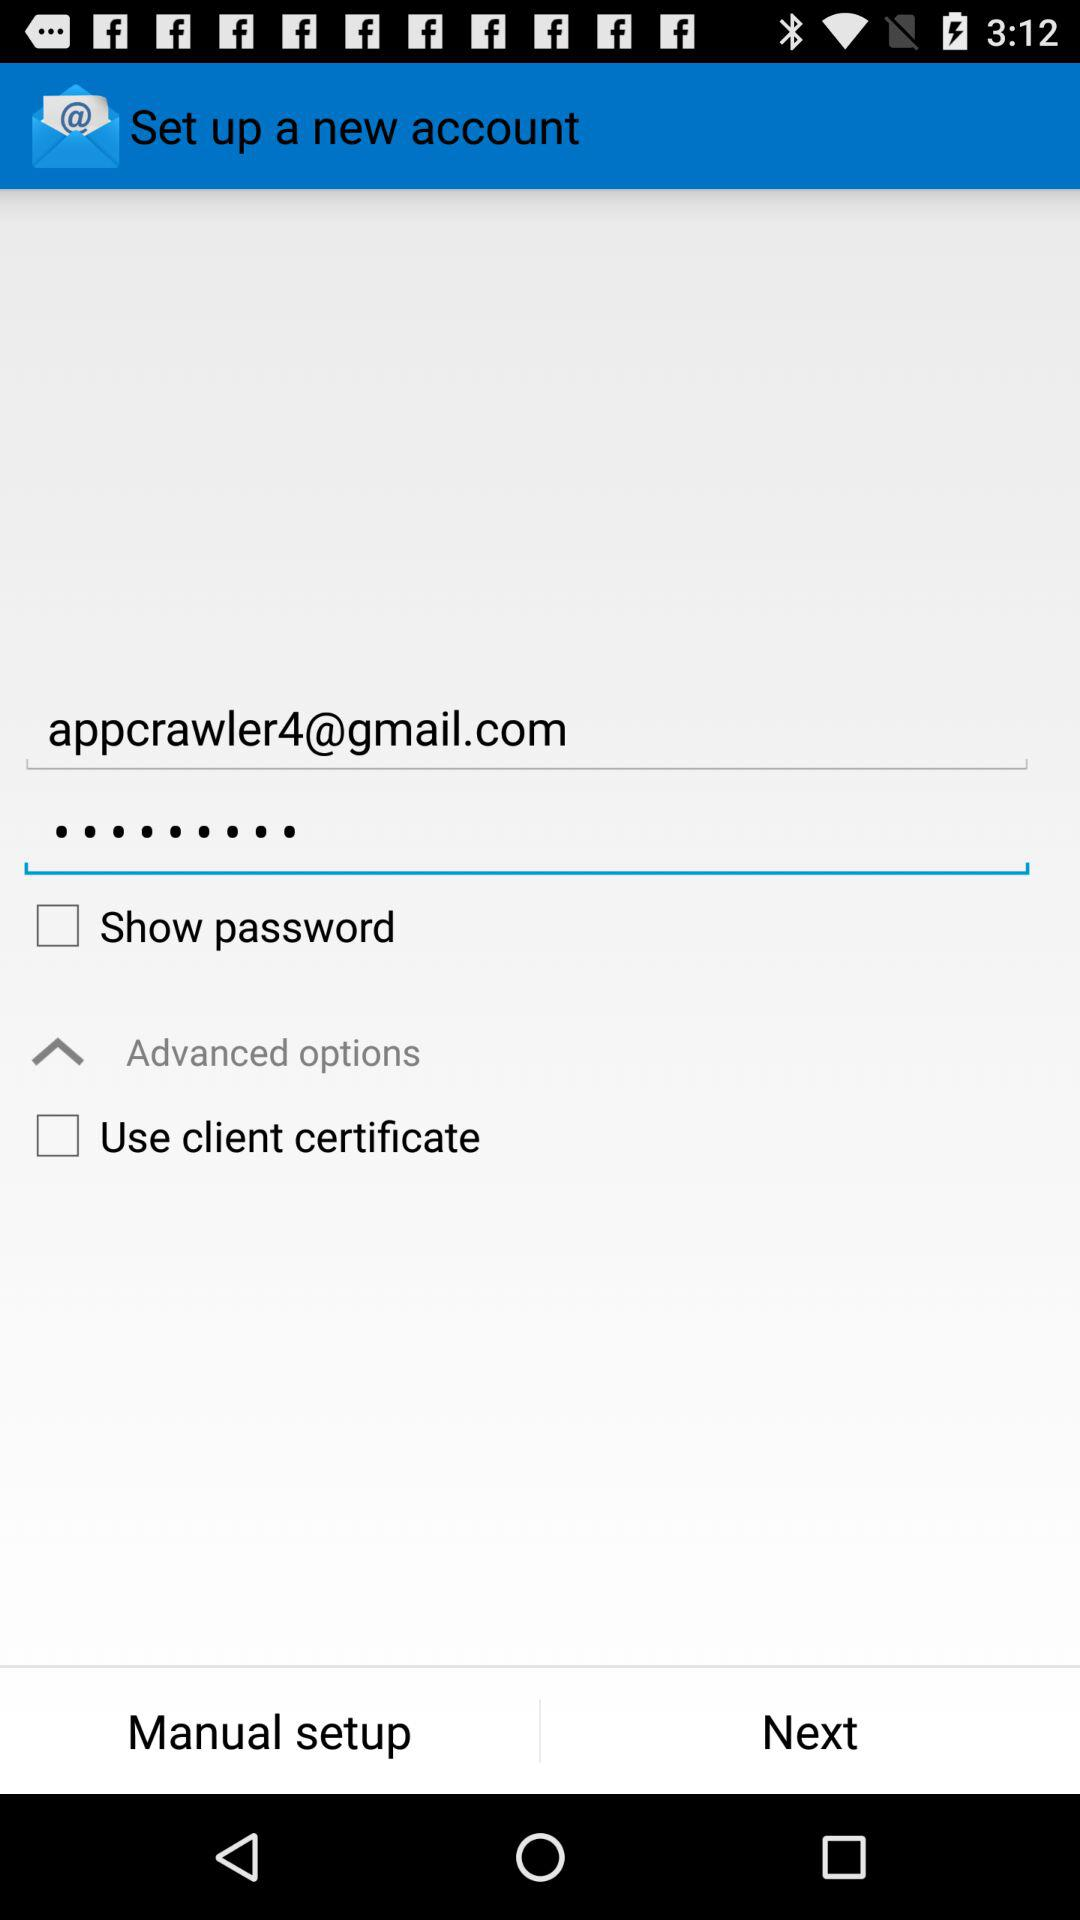What's the status of the "Use client certificate" in the advanced options? The status of the "Use client certificate" is "off". 